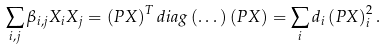<formula> <loc_0><loc_0><loc_500><loc_500>\sum _ { i , j } \beta _ { i , j } X _ { i } X _ { j } = \left ( P X \right ) ^ { T } d i a g \left ( \dots \right ) \left ( P X \right ) = \sum _ { i } d _ { i } \left ( P X \right ) _ { i } ^ { 2 } .</formula> 